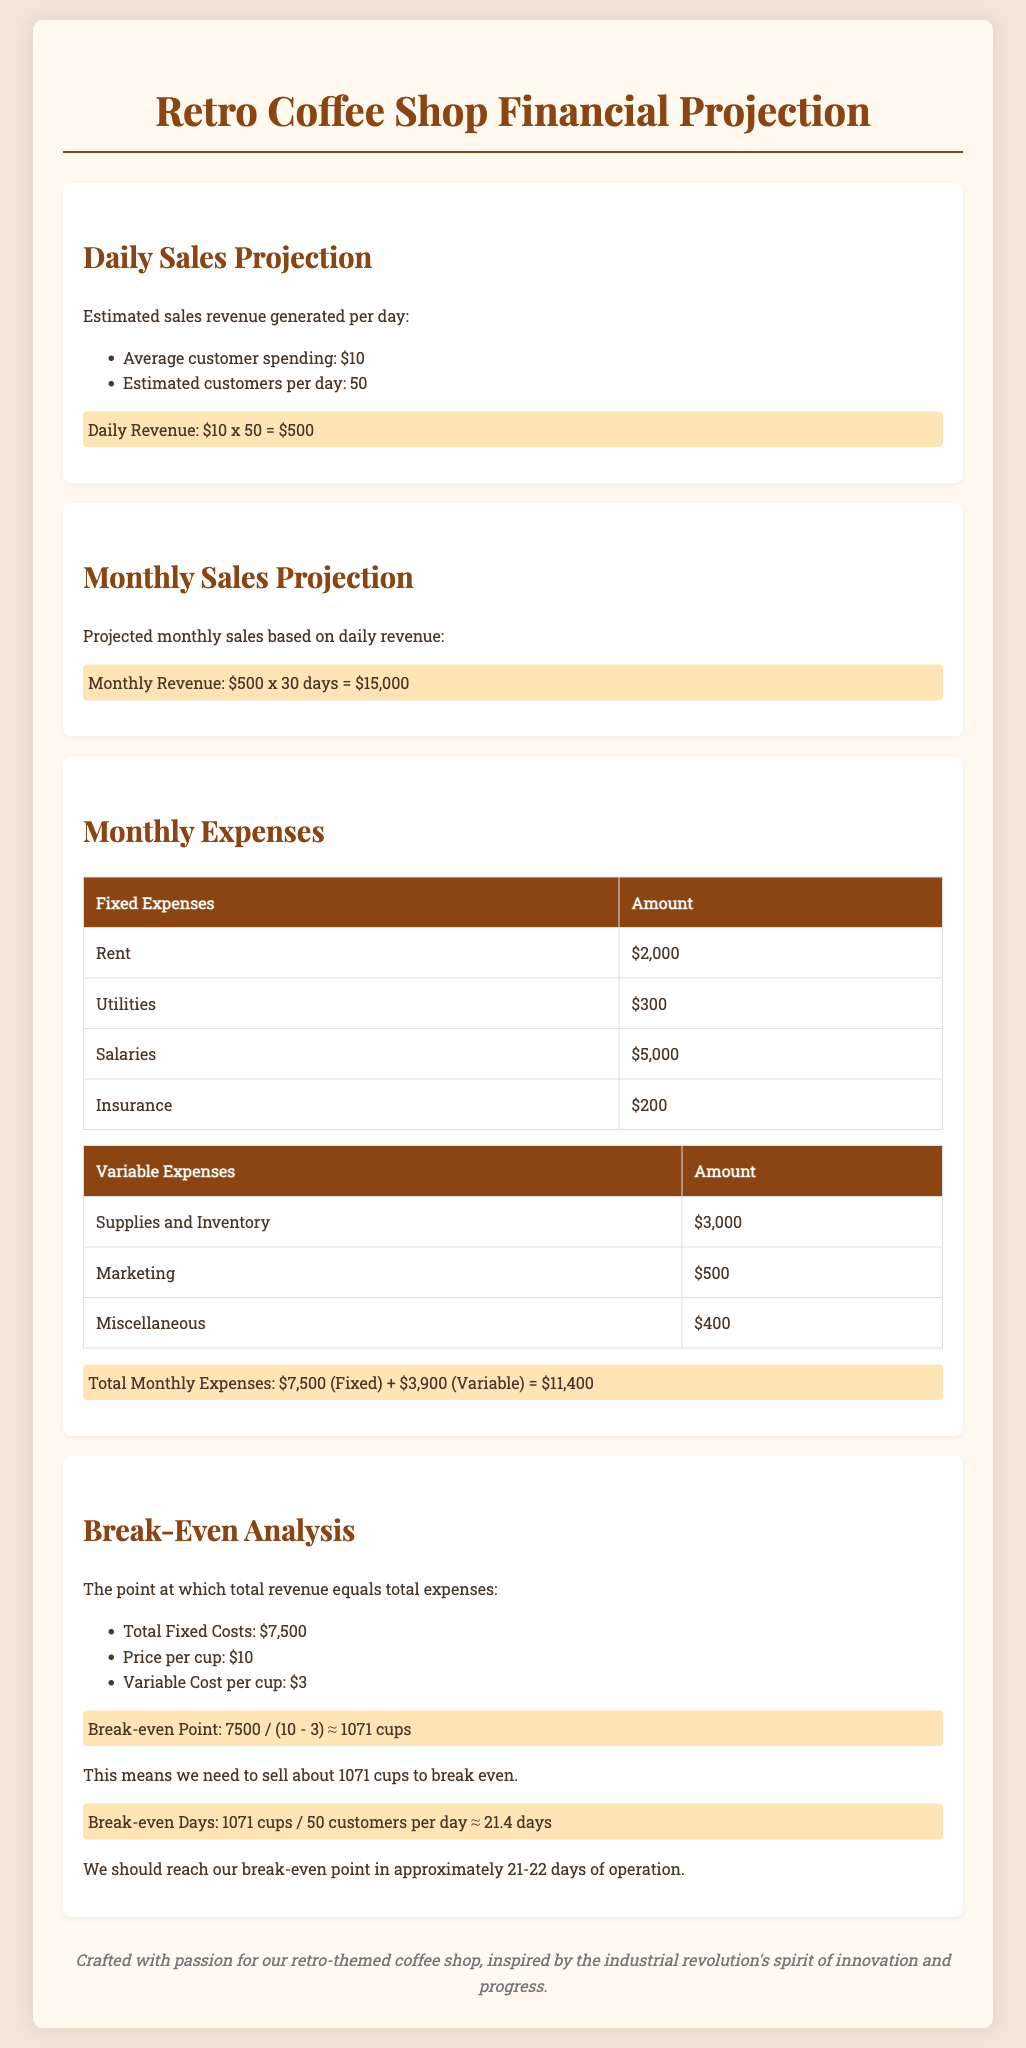What is the average customer spending? The document states that the average customer spending is $10.
Answer: $10 What is the estimated number of customers per day? The document outlines that the estimated number of customers per day is 50.
Answer: 50 What is the total monthly revenue? Monthly revenue is calculated as daily revenue multiplied by the number of days, which is $500 x 30 days = $15,000.
Answer: $15,000 What are the fixed expenses? The fixed expenses listed in the document include Rent, Utilities, Salaries, and Insurance.
Answer: $7,500 What is the total variable expense per month? The document states the variable expenses total $3,900, including Supplies, Marketing, and Miscellaneous costs.
Answer: $3,900 What is the break-even point in cups? The break-even point required to cover fixed costs is calculated as approximately 1,071 cups.
Answer: 1,071 cups How many days will it take to break even? The document indicates it will take about 21 to 22 days to reach the break-even point.
Answer: 21-22 days What is the total monthly expenses? The total monthly expenses, which include both fixed and variable costs, amount to $11,400.
Answer: $11,400 How much is allocated for marketing expenses? The document specifies the marketing expenses are set at $500 per month.
Answer: $500 